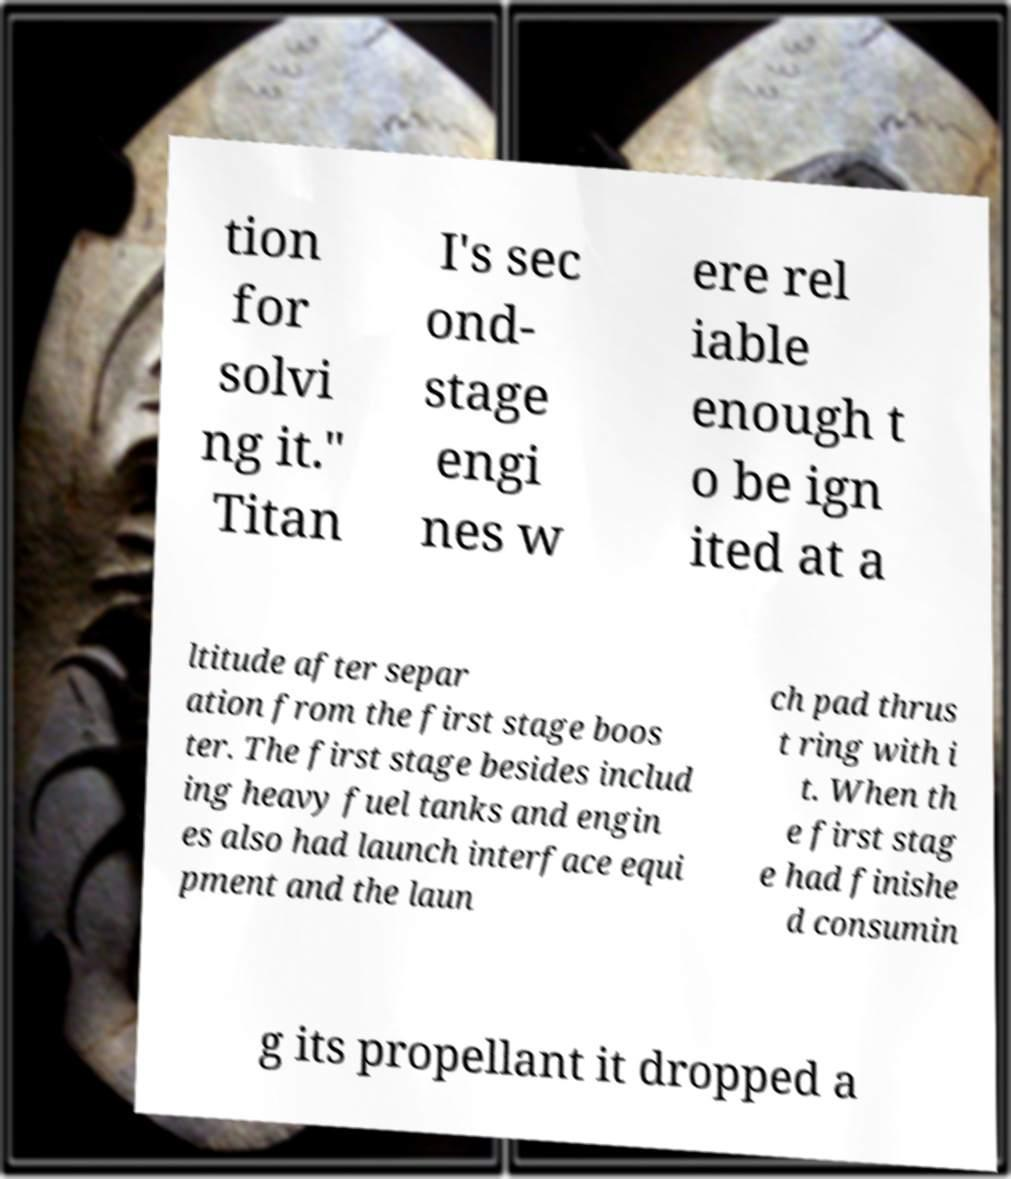Can you accurately transcribe the text from the provided image for me? tion for solvi ng it." Titan I's sec ond- stage engi nes w ere rel iable enough t o be ign ited at a ltitude after separ ation from the first stage boos ter. The first stage besides includ ing heavy fuel tanks and engin es also had launch interface equi pment and the laun ch pad thrus t ring with i t. When th e first stag e had finishe d consumin g its propellant it dropped a 